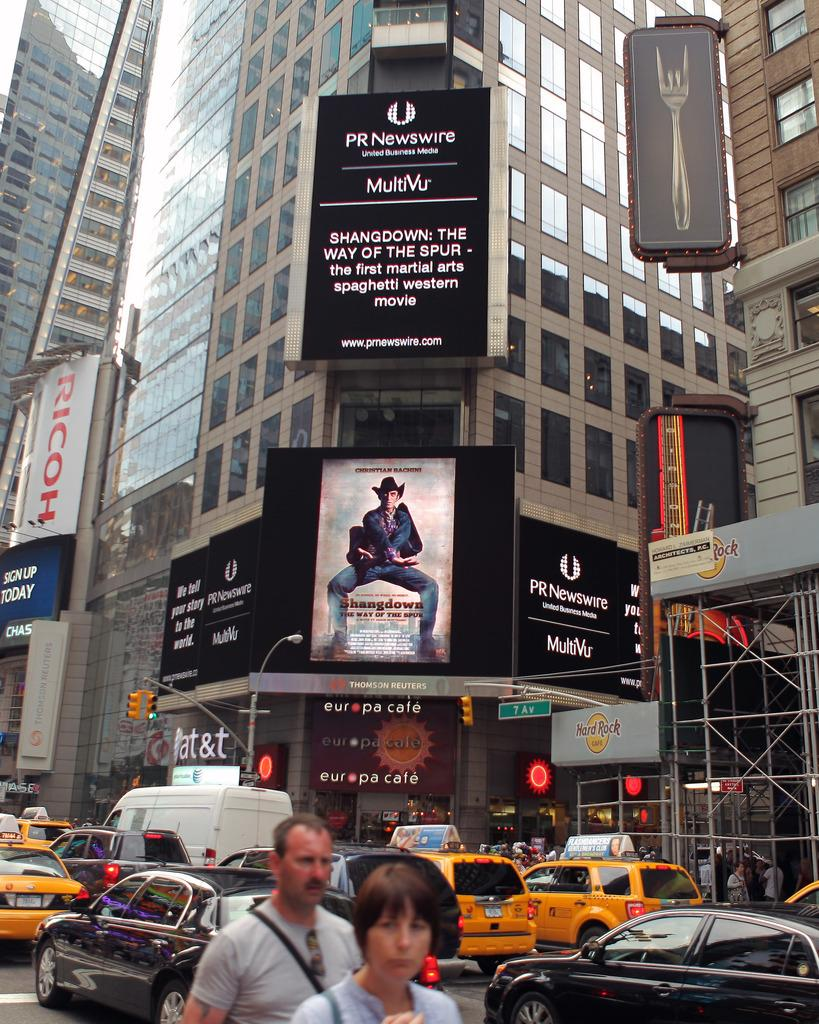Provide a one-sentence caption for the provided image. A billboard for PR Newswire hangs over a picture of a man in a cowboy hat. 